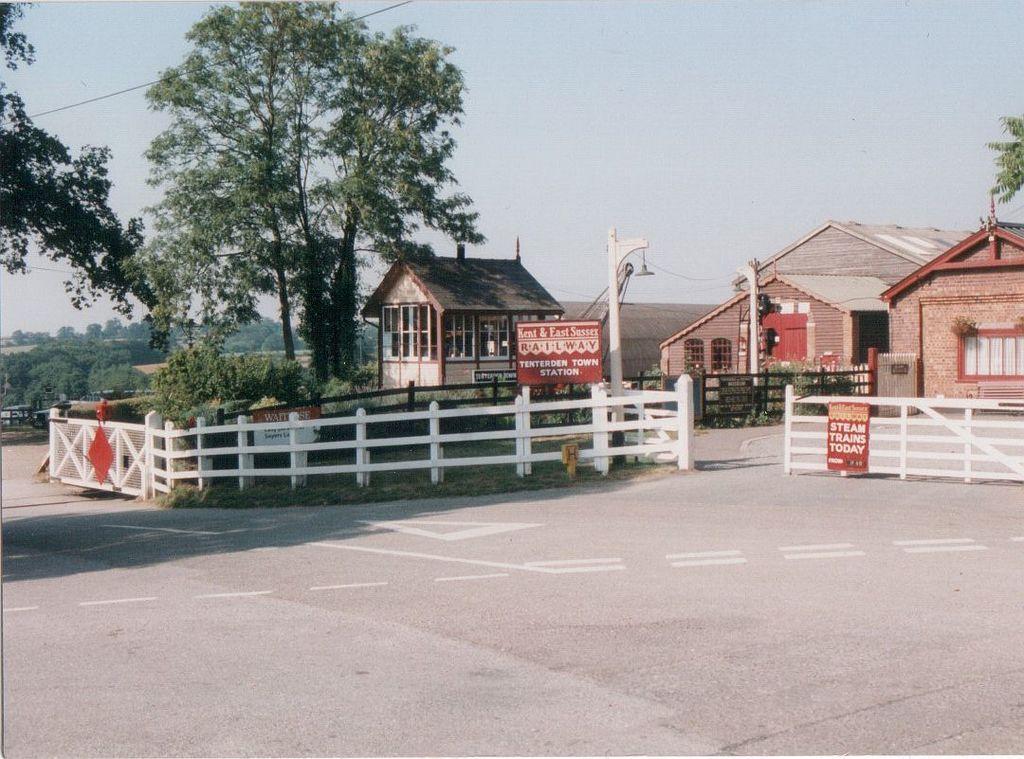Please provide a concise description of this image. In this picture I can see the shed, building and house. In the center I can see the sign boards, streetlights and wooden fencing. Near to that I can see the plants and grass. In the background I can see the mountain and many trees. At the top there is a sky and electric wire. At the bottom there is a road. 